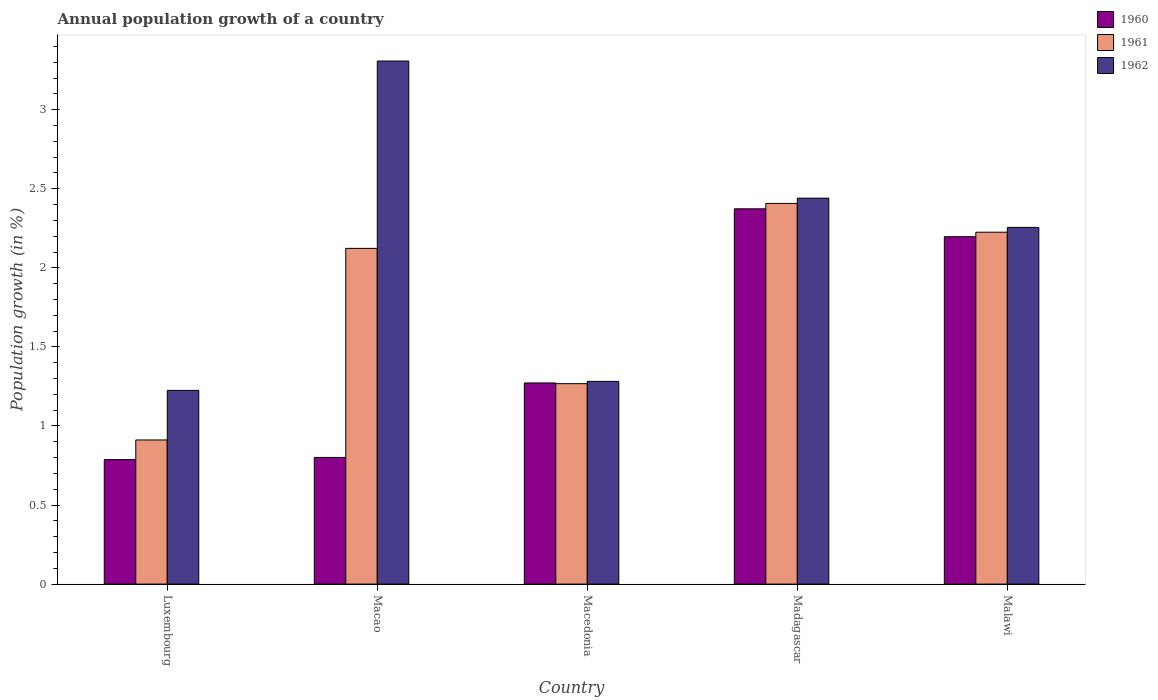How many different coloured bars are there?
Make the answer very short. 3. Are the number of bars per tick equal to the number of legend labels?
Provide a succinct answer. Yes. How many bars are there on the 1st tick from the right?
Provide a short and direct response. 3. What is the label of the 4th group of bars from the left?
Provide a succinct answer. Madagascar. What is the annual population growth in 1961 in Macao?
Provide a short and direct response. 2.12. Across all countries, what is the maximum annual population growth in 1960?
Give a very brief answer. 2.37. Across all countries, what is the minimum annual population growth in 1961?
Provide a short and direct response. 0.91. In which country was the annual population growth in 1962 maximum?
Offer a very short reply. Macao. In which country was the annual population growth in 1960 minimum?
Your response must be concise. Luxembourg. What is the total annual population growth in 1962 in the graph?
Ensure brevity in your answer.  10.51. What is the difference between the annual population growth in 1960 in Macedonia and that in Malawi?
Give a very brief answer. -0.92. What is the difference between the annual population growth in 1960 in Macedonia and the annual population growth in 1961 in Macao?
Keep it short and to the point. -0.85. What is the average annual population growth in 1962 per country?
Ensure brevity in your answer.  2.1. What is the difference between the annual population growth of/in 1960 and annual population growth of/in 1961 in Macao?
Offer a terse response. -1.32. In how many countries, is the annual population growth in 1961 greater than 2.7 %?
Ensure brevity in your answer.  0. What is the ratio of the annual population growth in 1962 in Madagascar to that in Malawi?
Make the answer very short. 1.08. What is the difference between the highest and the second highest annual population growth in 1960?
Provide a succinct answer. -1.1. What is the difference between the highest and the lowest annual population growth in 1960?
Ensure brevity in your answer.  1.59. Is the sum of the annual population growth in 1960 in Macedonia and Madagascar greater than the maximum annual population growth in 1961 across all countries?
Your answer should be compact. Yes. What does the 3rd bar from the left in Macedonia represents?
Ensure brevity in your answer.  1962. What does the 2nd bar from the right in Madagascar represents?
Provide a short and direct response. 1961. Is it the case that in every country, the sum of the annual population growth in 1960 and annual population growth in 1961 is greater than the annual population growth in 1962?
Your answer should be compact. No. Are all the bars in the graph horizontal?
Keep it short and to the point. No. What is the difference between two consecutive major ticks on the Y-axis?
Give a very brief answer. 0.5. Are the values on the major ticks of Y-axis written in scientific E-notation?
Your answer should be very brief. No. Does the graph contain grids?
Your answer should be compact. No. Where does the legend appear in the graph?
Provide a short and direct response. Top right. What is the title of the graph?
Ensure brevity in your answer.  Annual population growth of a country. What is the label or title of the Y-axis?
Your response must be concise. Population growth (in %). What is the Population growth (in %) in 1960 in Luxembourg?
Offer a very short reply. 0.79. What is the Population growth (in %) in 1961 in Luxembourg?
Your answer should be very brief. 0.91. What is the Population growth (in %) of 1962 in Luxembourg?
Make the answer very short. 1.22. What is the Population growth (in %) in 1960 in Macao?
Keep it short and to the point. 0.8. What is the Population growth (in %) of 1961 in Macao?
Your response must be concise. 2.12. What is the Population growth (in %) of 1962 in Macao?
Provide a succinct answer. 3.31. What is the Population growth (in %) in 1960 in Macedonia?
Provide a short and direct response. 1.27. What is the Population growth (in %) of 1961 in Macedonia?
Offer a terse response. 1.27. What is the Population growth (in %) of 1962 in Macedonia?
Give a very brief answer. 1.28. What is the Population growth (in %) in 1960 in Madagascar?
Your answer should be compact. 2.37. What is the Population growth (in %) in 1961 in Madagascar?
Give a very brief answer. 2.41. What is the Population growth (in %) in 1962 in Madagascar?
Your answer should be very brief. 2.44. What is the Population growth (in %) of 1960 in Malawi?
Offer a very short reply. 2.2. What is the Population growth (in %) in 1961 in Malawi?
Your response must be concise. 2.23. What is the Population growth (in %) in 1962 in Malawi?
Give a very brief answer. 2.26. Across all countries, what is the maximum Population growth (in %) in 1960?
Your response must be concise. 2.37. Across all countries, what is the maximum Population growth (in %) of 1961?
Keep it short and to the point. 2.41. Across all countries, what is the maximum Population growth (in %) of 1962?
Ensure brevity in your answer.  3.31. Across all countries, what is the minimum Population growth (in %) of 1960?
Provide a short and direct response. 0.79. Across all countries, what is the minimum Population growth (in %) of 1961?
Give a very brief answer. 0.91. Across all countries, what is the minimum Population growth (in %) of 1962?
Your answer should be compact. 1.22. What is the total Population growth (in %) of 1960 in the graph?
Ensure brevity in your answer.  7.43. What is the total Population growth (in %) of 1961 in the graph?
Your answer should be compact. 8.93. What is the total Population growth (in %) of 1962 in the graph?
Your response must be concise. 10.51. What is the difference between the Population growth (in %) in 1960 in Luxembourg and that in Macao?
Your response must be concise. -0.01. What is the difference between the Population growth (in %) in 1961 in Luxembourg and that in Macao?
Your answer should be compact. -1.21. What is the difference between the Population growth (in %) in 1962 in Luxembourg and that in Macao?
Your response must be concise. -2.08. What is the difference between the Population growth (in %) in 1960 in Luxembourg and that in Macedonia?
Your answer should be very brief. -0.48. What is the difference between the Population growth (in %) of 1961 in Luxembourg and that in Macedonia?
Give a very brief answer. -0.36. What is the difference between the Population growth (in %) in 1962 in Luxembourg and that in Macedonia?
Provide a succinct answer. -0.06. What is the difference between the Population growth (in %) of 1960 in Luxembourg and that in Madagascar?
Your response must be concise. -1.59. What is the difference between the Population growth (in %) in 1961 in Luxembourg and that in Madagascar?
Ensure brevity in your answer.  -1.5. What is the difference between the Population growth (in %) in 1962 in Luxembourg and that in Madagascar?
Provide a short and direct response. -1.22. What is the difference between the Population growth (in %) of 1960 in Luxembourg and that in Malawi?
Keep it short and to the point. -1.41. What is the difference between the Population growth (in %) of 1961 in Luxembourg and that in Malawi?
Provide a succinct answer. -1.31. What is the difference between the Population growth (in %) of 1962 in Luxembourg and that in Malawi?
Provide a succinct answer. -1.03. What is the difference between the Population growth (in %) in 1960 in Macao and that in Macedonia?
Your answer should be compact. -0.47. What is the difference between the Population growth (in %) in 1961 in Macao and that in Macedonia?
Your answer should be very brief. 0.86. What is the difference between the Population growth (in %) of 1962 in Macao and that in Macedonia?
Your response must be concise. 2.03. What is the difference between the Population growth (in %) of 1960 in Macao and that in Madagascar?
Provide a succinct answer. -1.57. What is the difference between the Population growth (in %) of 1961 in Macao and that in Madagascar?
Offer a terse response. -0.28. What is the difference between the Population growth (in %) of 1962 in Macao and that in Madagascar?
Give a very brief answer. 0.87. What is the difference between the Population growth (in %) in 1960 in Macao and that in Malawi?
Offer a very short reply. -1.4. What is the difference between the Population growth (in %) of 1961 in Macao and that in Malawi?
Offer a terse response. -0.1. What is the difference between the Population growth (in %) of 1962 in Macao and that in Malawi?
Make the answer very short. 1.05. What is the difference between the Population growth (in %) of 1960 in Macedonia and that in Madagascar?
Offer a very short reply. -1.1. What is the difference between the Population growth (in %) of 1961 in Macedonia and that in Madagascar?
Offer a very short reply. -1.14. What is the difference between the Population growth (in %) in 1962 in Macedonia and that in Madagascar?
Your answer should be compact. -1.16. What is the difference between the Population growth (in %) in 1960 in Macedonia and that in Malawi?
Ensure brevity in your answer.  -0.92. What is the difference between the Population growth (in %) of 1961 in Macedonia and that in Malawi?
Keep it short and to the point. -0.96. What is the difference between the Population growth (in %) in 1962 in Macedonia and that in Malawi?
Ensure brevity in your answer.  -0.97. What is the difference between the Population growth (in %) in 1960 in Madagascar and that in Malawi?
Offer a terse response. 0.18. What is the difference between the Population growth (in %) in 1961 in Madagascar and that in Malawi?
Your answer should be compact. 0.18. What is the difference between the Population growth (in %) of 1962 in Madagascar and that in Malawi?
Keep it short and to the point. 0.18. What is the difference between the Population growth (in %) of 1960 in Luxembourg and the Population growth (in %) of 1961 in Macao?
Make the answer very short. -1.34. What is the difference between the Population growth (in %) of 1960 in Luxembourg and the Population growth (in %) of 1962 in Macao?
Provide a short and direct response. -2.52. What is the difference between the Population growth (in %) in 1961 in Luxembourg and the Population growth (in %) in 1962 in Macao?
Provide a succinct answer. -2.4. What is the difference between the Population growth (in %) in 1960 in Luxembourg and the Population growth (in %) in 1961 in Macedonia?
Offer a very short reply. -0.48. What is the difference between the Population growth (in %) in 1960 in Luxembourg and the Population growth (in %) in 1962 in Macedonia?
Provide a short and direct response. -0.49. What is the difference between the Population growth (in %) in 1961 in Luxembourg and the Population growth (in %) in 1962 in Macedonia?
Provide a succinct answer. -0.37. What is the difference between the Population growth (in %) of 1960 in Luxembourg and the Population growth (in %) of 1961 in Madagascar?
Your response must be concise. -1.62. What is the difference between the Population growth (in %) in 1960 in Luxembourg and the Population growth (in %) in 1962 in Madagascar?
Offer a very short reply. -1.65. What is the difference between the Population growth (in %) in 1961 in Luxembourg and the Population growth (in %) in 1962 in Madagascar?
Your response must be concise. -1.53. What is the difference between the Population growth (in %) in 1960 in Luxembourg and the Population growth (in %) in 1961 in Malawi?
Your answer should be very brief. -1.44. What is the difference between the Population growth (in %) of 1960 in Luxembourg and the Population growth (in %) of 1962 in Malawi?
Provide a short and direct response. -1.47. What is the difference between the Population growth (in %) in 1961 in Luxembourg and the Population growth (in %) in 1962 in Malawi?
Your answer should be very brief. -1.34. What is the difference between the Population growth (in %) in 1960 in Macao and the Population growth (in %) in 1961 in Macedonia?
Your response must be concise. -0.47. What is the difference between the Population growth (in %) in 1960 in Macao and the Population growth (in %) in 1962 in Macedonia?
Ensure brevity in your answer.  -0.48. What is the difference between the Population growth (in %) of 1961 in Macao and the Population growth (in %) of 1962 in Macedonia?
Offer a very short reply. 0.84. What is the difference between the Population growth (in %) in 1960 in Macao and the Population growth (in %) in 1961 in Madagascar?
Give a very brief answer. -1.61. What is the difference between the Population growth (in %) in 1960 in Macao and the Population growth (in %) in 1962 in Madagascar?
Offer a very short reply. -1.64. What is the difference between the Population growth (in %) in 1961 in Macao and the Population growth (in %) in 1962 in Madagascar?
Keep it short and to the point. -0.32. What is the difference between the Population growth (in %) of 1960 in Macao and the Population growth (in %) of 1961 in Malawi?
Offer a very short reply. -1.42. What is the difference between the Population growth (in %) of 1960 in Macao and the Population growth (in %) of 1962 in Malawi?
Ensure brevity in your answer.  -1.45. What is the difference between the Population growth (in %) of 1961 in Macao and the Population growth (in %) of 1962 in Malawi?
Provide a short and direct response. -0.13. What is the difference between the Population growth (in %) in 1960 in Macedonia and the Population growth (in %) in 1961 in Madagascar?
Provide a short and direct response. -1.14. What is the difference between the Population growth (in %) in 1960 in Macedonia and the Population growth (in %) in 1962 in Madagascar?
Provide a succinct answer. -1.17. What is the difference between the Population growth (in %) of 1961 in Macedonia and the Population growth (in %) of 1962 in Madagascar?
Give a very brief answer. -1.17. What is the difference between the Population growth (in %) in 1960 in Macedonia and the Population growth (in %) in 1961 in Malawi?
Ensure brevity in your answer.  -0.95. What is the difference between the Population growth (in %) in 1960 in Macedonia and the Population growth (in %) in 1962 in Malawi?
Provide a succinct answer. -0.98. What is the difference between the Population growth (in %) of 1961 in Macedonia and the Population growth (in %) of 1962 in Malawi?
Your answer should be very brief. -0.99. What is the difference between the Population growth (in %) of 1960 in Madagascar and the Population growth (in %) of 1961 in Malawi?
Provide a short and direct response. 0.15. What is the difference between the Population growth (in %) of 1960 in Madagascar and the Population growth (in %) of 1962 in Malawi?
Provide a succinct answer. 0.12. What is the difference between the Population growth (in %) of 1961 in Madagascar and the Population growth (in %) of 1962 in Malawi?
Ensure brevity in your answer.  0.15. What is the average Population growth (in %) in 1960 per country?
Make the answer very short. 1.49. What is the average Population growth (in %) in 1961 per country?
Keep it short and to the point. 1.79. What is the average Population growth (in %) of 1962 per country?
Provide a short and direct response. 2.1. What is the difference between the Population growth (in %) in 1960 and Population growth (in %) in 1961 in Luxembourg?
Offer a terse response. -0.12. What is the difference between the Population growth (in %) in 1960 and Population growth (in %) in 1962 in Luxembourg?
Your answer should be compact. -0.44. What is the difference between the Population growth (in %) in 1961 and Population growth (in %) in 1962 in Luxembourg?
Ensure brevity in your answer.  -0.31. What is the difference between the Population growth (in %) in 1960 and Population growth (in %) in 1961 in Macao?
Offer a very short reply. -1.32. What is the difference between the Population growth (in %) of 1960 and Population growth (in %) of 1962 in Macao?
Give a very brief answer. -2.51. What is the difference between the Population growth (in %) of 1961 and Population growth (in %) of 1962 in Macao?
Your answer should be very brief. -1.18. What is the difference between the Population growth (in %) of 1960 and Population growth (in %) of 1961 in Macedonia?
Give a very brief answer. 0. What is the difference between the Population growth (in %) of 1960 and Population growth (in %) of 1962 in Macedonia?
Ensure brevity in your answer.  -0.01. What is the difference between the Population growth (in %) in 1961 and Population growth (in %) in 1962 in Macedonia?
Make the answer very short. -0.01. What is the difference between the Population growth (in %) of 1960 and Population growth (in %) of 1961 in Madagascar?
Provide a succinct answer. -0.03. What is the difference between the Population growth (in %) of 1960 and Population growth (in %) of 1962 in Madagascar?
Make the answer very short. -0.07. What is the difference between the Population growth (in %) in 1961 and Population growth (in %) in 1962 in Madagascar?
Give a very brief answer. -0.03. What is the difference between the Population growth (in %) of 1960 and Population growth (in %) of 1961 in Malawi?
Offer a terse response. -0.03. What is the difference between the Population growth (in %) in 1960 and Population growth (in %) in 1962 in Malawi?
Provide a succinct answer. -0.06. What is the difference between the Population growth (in %) of 1961 and Population growth (in %) of 1962 in Malawi?
Keep it short and to the point. -0.03. What is the ratio of the Population growth (in %) in 1960 in Luxembourg to that in Macao?
Provide a succinct answer. 0.98. What is the ratio of the Population growth (in %) in 1961 in Luxembourg to that in Macao?
Your answer should be very brief. 0.43. What is the ratio of the Population growth (in %) in 1962 in Luxembourg to that in Macao?
Offer a very short reply. 0.37. What is the ratio of the Population growth (in %) in 1960 in Luxembourg to that in Macedonia?
Offer a terse response. 0.62. What is the ratio of the Population growth (in %) of 1961 in Luxembourg to that in Macedonia?
Offer a very short reply. 0.72. What is the ratio of the Population growth (in %) of 1962 in Luxembourg to that in Macedonia?
Offer a terse response. 0.96. What is the ratio of the Population growth (in %) in 1960 in Luxembourg to that in Madagascar?
Your response must be concise. 0.33. What is the ratio of the Population growth (in %) of 1961 in Luxembourg to that in Madagascar?
Provide a succinct answer. 0.38. What is the ratio of the Population growth (in %) of 1962 in Luxembourg to that in Madagascar?
Make the answer very short. 0.5. What is the ratio of the Population growth (in %) of 1960 in Luxembourg to that in Malawi?
Your answer should be compact. 0.36. What is the ratio of the Population growth (in %) of 1961 in Luxembourg to that in Malawi?
Provide a short and direct response. 0.41. What is the ratio of the Population growth (in %) of 1962 in Luxembourg to that in Malawi?
Give a very brief answer. 0.54. What is the ratio of the Population growth (in %) in 1960 in Macao to that in Macedonia?
Your response must be concise. 0.63. What is the ratio of the Population growth (in %) in 1961 in Macao to that in Macedonia?
Provide a succinct answer. 1.68. What is the ratio of the Population growth (in %) in 1962 in Macao to that in Macedonia?
Offer a very short reply. 2.58. What is the ratio of the Population growth (in %) of 1960 in Macao to that in Madagascar?
Your response must be concise. 0.34. What is the ratio of the Population growth (in %) in 1961 in Macao to that in Madagascar?
Make the answer very short. 0.88. What is the ratio of the Population growth (in %) in 1962 in Macao to that in Madagascar?
Your answer should be compact. 1.36. What is the ratio of the Population growth (in %) in 1960 in Macao to that in Malawi?
Offer a very short reply. 0.36. What is the ratio of the Population growth (in %) in 1961 in Macao to that in Malawi?
Offer a terse response. 0.95. What is the ratio of the Population growth (in %) in 1962 in Macao to that in Malawi?
Make the answer very short. 1.47. What is the ratio of the Population growth (in %) of 1960 in Macedonia to that in Madagascar?
Give a very brief answer. 0.54. What is the ratio of the Population growth (in %) of 1961 in Macedonia to that in Madagascar?
Give a very brief answer. 0.53. What is the ratio of the Population growth (in %) in 1962 in Macedonia to that in Madagascar?
Provide a succinct answer. 0.53. What is the ratio of the Population growth (in %) in 1960 in Macedonia to that in Malawi?
Your response must be concise. 0.58. What is the ratio of the Population growth (in %) of 1961 in Macedonia to that in Malawi?
Ensure brevity in your answer.  0.57. What is the ratio of the Population growth (in %) of 1962 in Macedonia to that in Malawi?
Give a very brief answer. 0.57. What is the ratio of the Population growth (in %) in 1960 in Madagascar to that in Malawi?
Provide a succinct answer. 1.08. What is the ratio of the Population growth (in %) of 1961 in Madagascar to that in Malawi?
Your answer should be very brief. 1.08. What is the ratio of the Population growth (in %) of 1962 in Madagascar to that in Malawi?
Make the answer very short. 1.08. What is the difference between the highest and the second highest Population growth (in %) in 1960?
Give a very brief answer. 0.18. What is the difference between the highest and the second highest Population growth (in %) in 1961?
Offer a terse response. 0.18. What is the difference between the highest and the second highest Population growth (in %) in 1962?
Provide a short and direct response. 0.87. What is the difference between the highest and the lowest Population growth (in %) in 1960?
Provide a short and direct response. 1.59. What is the difference between the highest and the lowest Population growth (in %) in 1961?
Provide a short and direct response. 1.5. What is the difference between the highest and the lowest Population growth (in %) in 1962?
Make the answer very short. 2.08. 